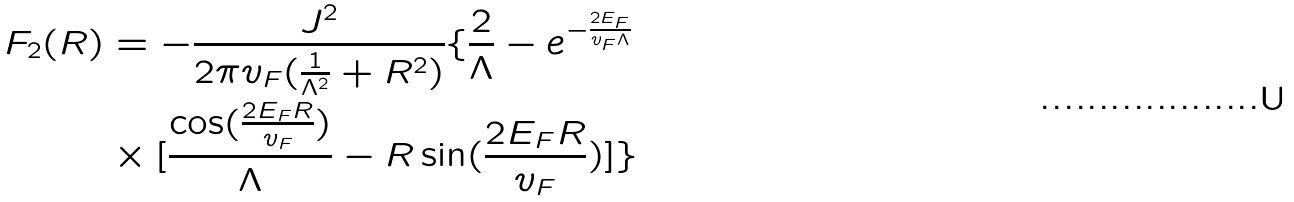<formula> <loc_0><loc_0><loc_500><loc_500>F _ { 2 } ( R ) & = - \frac { J ^ { 2 } } { 2 \pi v _ { F } ( \frac { 1 } { \Lambda ^ { 2 } } + R ^ { 2 } ) } \{ \frac { 2 } { \Lambda } - e ^ { - \frac { 2 E _ { F } } { v _ { F } \Lambda } } \\ & \times [ \frac { \cos ( \frac { 2 E _ { F } R } { v _ { F } } ) } { \Lambda } - R \sin ( \frac { 2 E _ { F } R } { v _ { F } } ) ] \}</formula> 